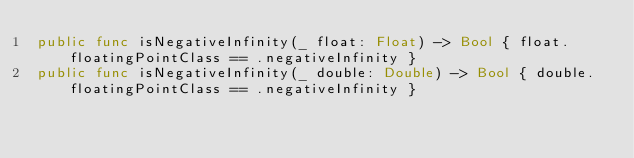Convert code to text. <code><loc_0><loc_0><loc_500><loc_500><_Swift_>public func isNegativeInfinity(_ float: Float) -> Bool { float.floatingPointClass == .negativeInfinity }
public func isNegativeInfinity(_ double: Double) -> Bool { double.floatingPointClass == .negativeInfinity }
</code> 